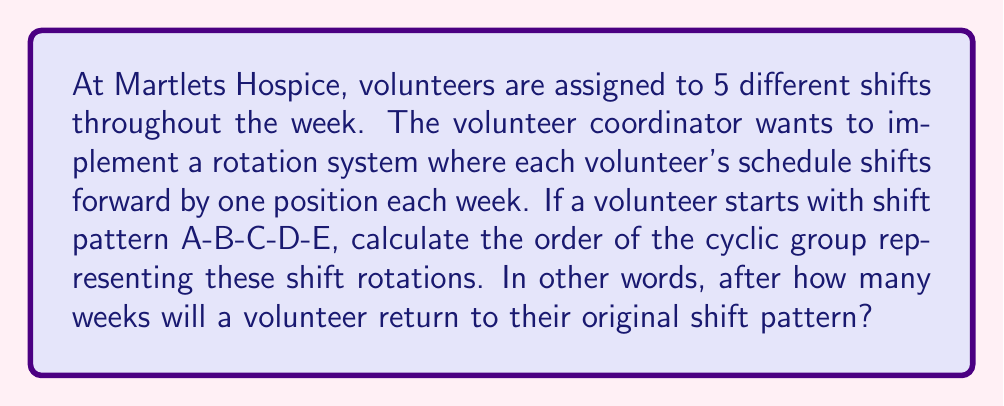What is the answer to this math problem? Let's approach this step-by-step:

1) First, we need to understand what the question is asking. We're dealing with a cyclic group where each element represents a particular shift pattern.

2) The initial pattern is A-B-C-D-E. Let's see how it changes each week:
   Week 1: A-B-C-D-E
   Week 2: E-A-B-C-D
   Week 3: D-E-A-B-C
   Week 4: C-D-E-A-B
   Week 5: B-C-D-E-A

3) We can see that after 5 weeks, the pattern returns to A-B-C-D-E.

4) In group theory terms, we're looking at the cyclic group generated by the permutation $\sigma = (ABCDE)$.

5) The order of an element in a group is the smallest positive integer $n$ such that $\sigma^n = e$, where $e$ is the identity element.

6) In this case, $\sigma^5 = e$, because after 5 applications of the shift, we return to the original pattern.

7) Therefore, the order of this cyclic group is 5.

Mathematically, we can write this as:

$$|\langle \sigma \rangle| = 5$$

where $\langle \sigma \rangle$ denotes the cyclic group generated by $\sigma$.
Answer: The order of the cyclic group representing shift rotations is 5. 